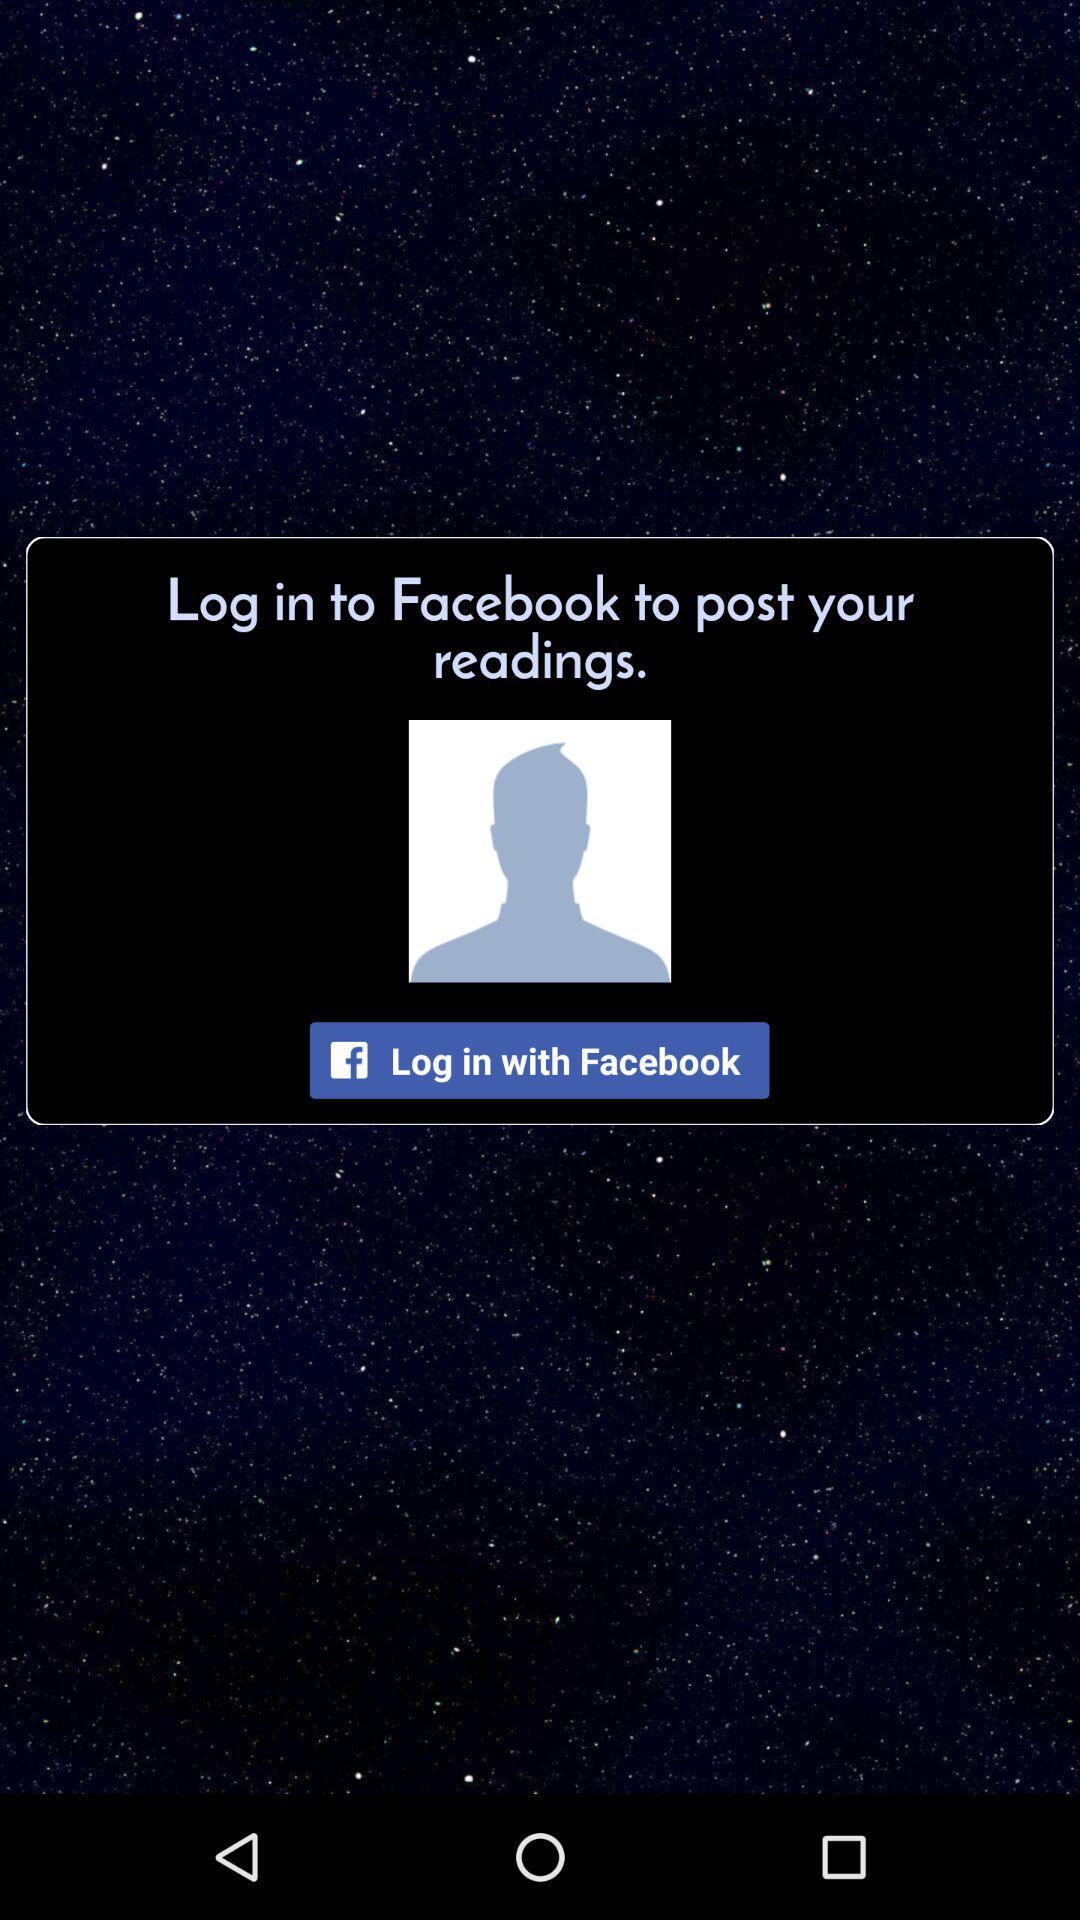How can we post readings? You can post your reading by logging in to Facebook. 